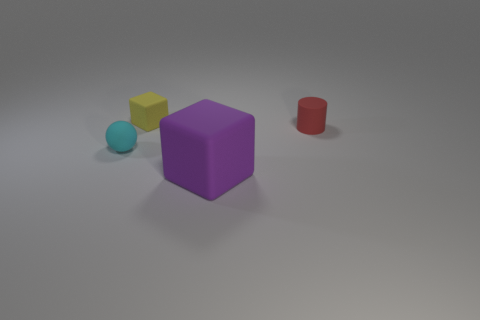Add 1 brown metal things. How many objects exist? 5 Subtract all small rubber things. Subtract all tiny red blocks. How many objects are left? 1 Add 1 purple rubber cubes. How many purple rubber cubes are left? 2 Add 4 tiny yellow cubes. How many tiny yellow cubes exist? 5 Subtract 0 yellow spheres. How many objects are left? 4 Subtract all cylinders. How many objects are left? 3 